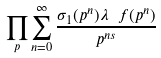Convert formula to latex. <formula><loc_0><loc_0><loc_500><loc_500>\prod _ { p } \sum _ { n = 0 } ^ { \infty } \frac { \sigma _ { 1 } ( p ^ { n } ) \lambda _ { \ } f ( p ^ { n } ) } { p ^ { n s } }</formula> 